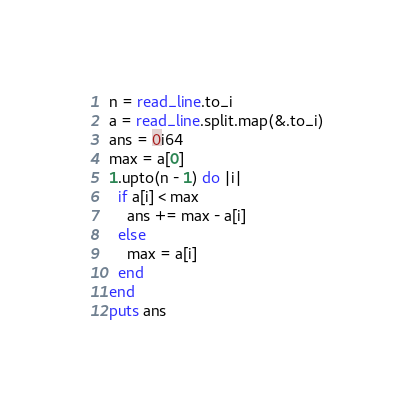Convert code to text. <code><loc_0><loc_0><loc_500><loc_500><_Crystal_>n = read_line.to_i
a = read_line.split.map(&.to_i)
ans = 0i64
max = a[0]
1.upto(n - 1) do |i|
  if a[i] < max
    ans += max - a[i]
  else
    max = a[i]
  end
end
puts ans
</code> 